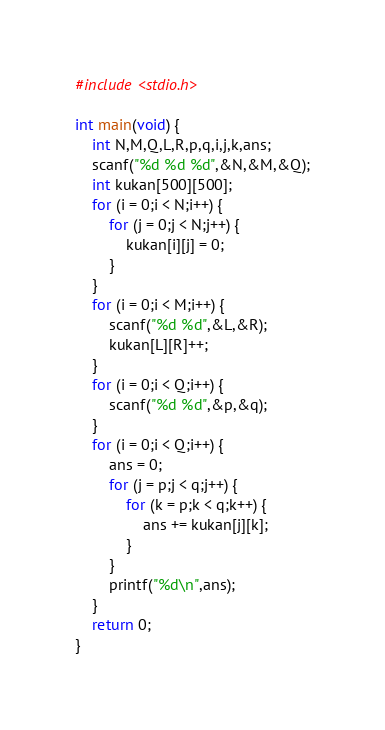<code> <loc_0><loc_0><loc_500><loc_500><_C_>#include <stdio.h>

int main(void) {
    int N,M,Q,L,R,p,q,i,j,k,ans;
    scanf("%d %d %d",&N,&M,&Q);
    int kukan[500][500];
    for (i = 0;i < N;i++) {
        for (j = 0;j < N;j++) {
            kukan[i][j] = 0;
        }
    }
    for (i = 0;i < M;i++) {
        scanf("%d %d",&L,&R);
        kukan[L][R]++;
    }
    for (i = 0;i < Q;i++) {
        scanf("%d %d",&p,&q);
    }
    for (i = 0;i < Q;i++) {
        ans = 0;
        for (j = p;j < q;j++) {
            for (k = p;k < q;k++) {
                ans += kukan[j][k];
            }
        }
        printf("%d\n",ans);
    }
    return 0;
}
</code> 